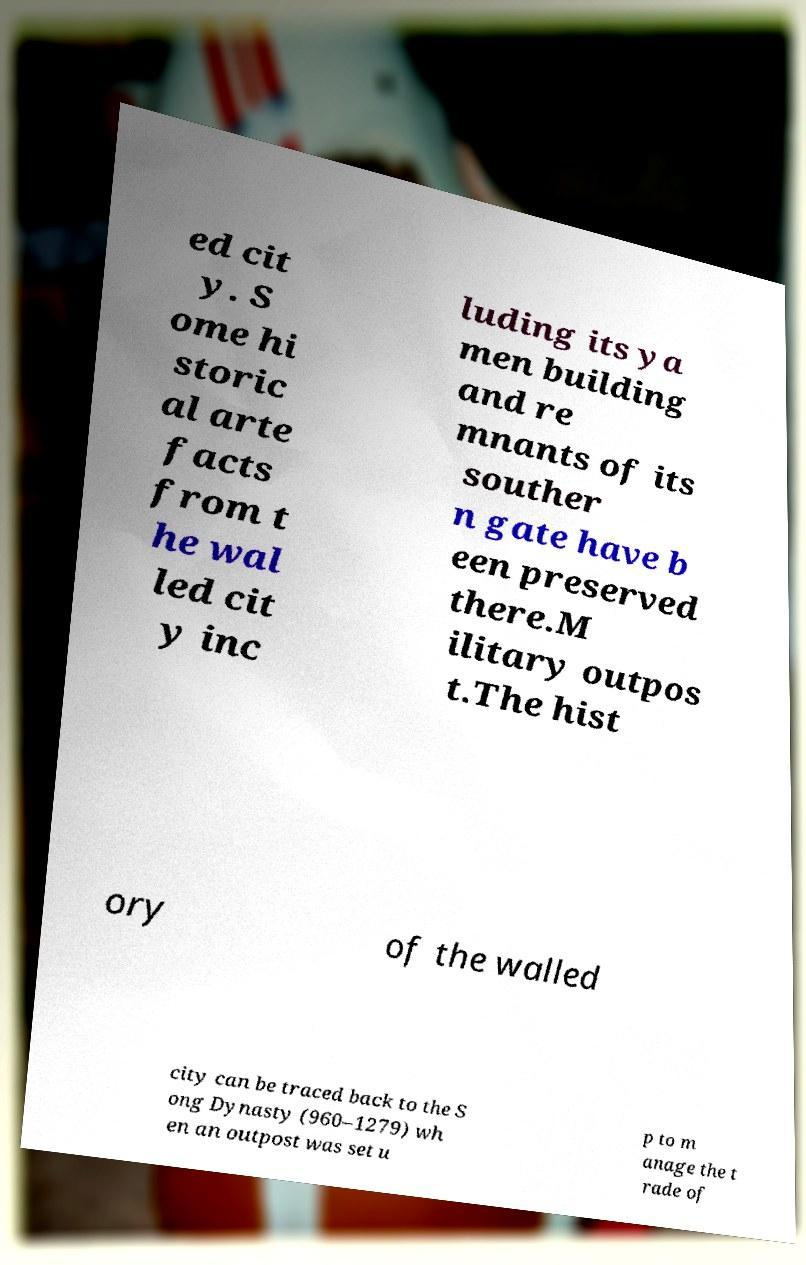Please identify and transcribe the text found in this image. ed cit y. S ome hi storic al arte facts from t he wal led cit y inc luding its ya men building and re mnants of its souther n gate have b een preserved there.M ilitary outpos t.The hist ory of the walled city can be traced back to the S ong Dynasty (960–1279) wh en an outpost was set u p to m anage the t rade of 